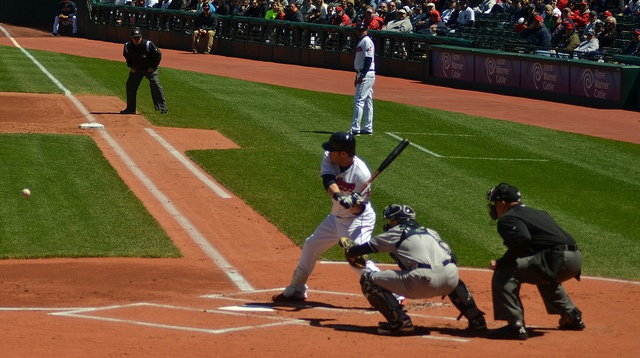Describe the objects in this image and their specific colors. I can see people in black, gray, darkgreen, and maroon tones, people in black, maroon, darkgray, and gray tones, people in black, gray, white, and maroon tones, people in black, darkgreen, and gray tones, and people in black, gray, darkgray, and lightgray tones in this image. 